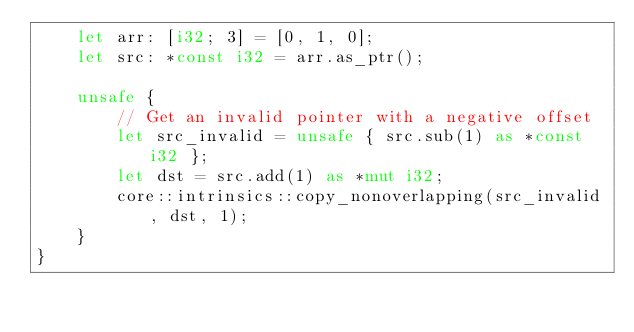<code> <loc_0><loc_0><loc_500><loc_500><_Rust_>    let arr: [i32; 3] = [0, 1, 0];
    let src: *const i32 = arr.as_ptr();

    unsafe {
        // Get an invalid pointer with a negative offset
        let src_invalid = unsafe { src.sub(1) as *const i32 };
        let dst = src.add(1) as *mut i32;
        core::intrinsics::copy_nonoverlapping(src_invalid, dst, 1);
    }
}
</code> 